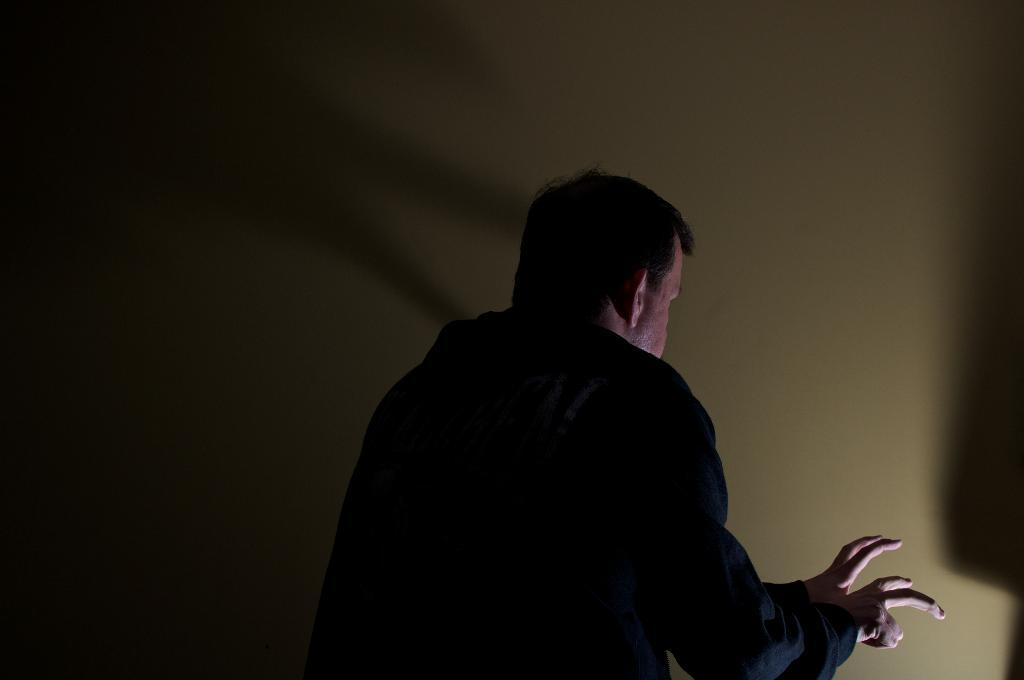Who or what is present in the image? There is a person in the image. What is the person wearing? The person is wearing a black dress. What can be seen in the background of the image? There is a wall in the image. What is the color of the wall? The wall is in cream color. Are there any alarms going off in the image? There is no indication of any alarms in the image. Can you see any snakes in the image? There are no snakes present in the image. 